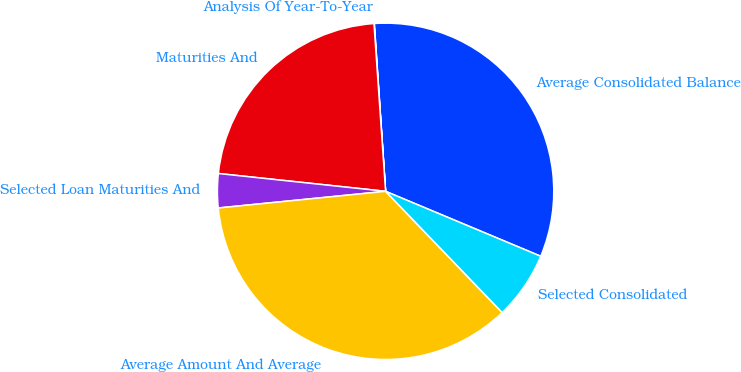Convert chart to OTSL. <chart><loc_0><loc_0><loc_500><loc_500><pie_chart><fcel>Average Consolidated Balance<fcel>Analysis Of Year-To-Year<fcel>Maturities And<fcel>Selected Loan Maturities And<fcel>Average Amount And Average<fcel>Selected Consolidated<nl><fcel>32.38%<fcel>0.03%<fcel>22.21%<fcel>3.27%<fcel>35.61%<fcel>6.5%<nl></chart> 